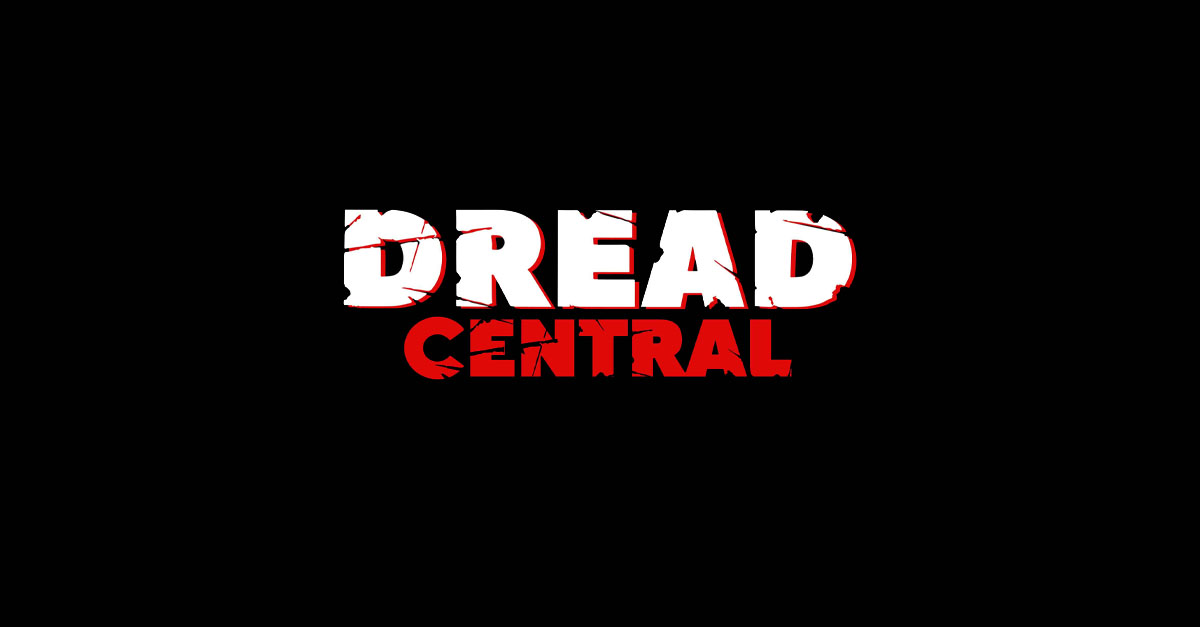Considering the stylistic choices made in the text design, what genre or themes might the entity represented by this text be associated with, and why do these design choices suggest that? The graphic text design, featuring the word 'DREAD' in bold, fragmented typography against a black backdrop, immediately evokes the essence of horror and psychological thriller themes. The jagged edges of the letters resemble sharp cuts or breaks, visualizing the notion of violence or disruption, which are hallmarks of suspenseful narratives. The color red, splattered like blood or highlighting danger, further reinforces the connection to horror, often used to convey intensity and high emotional stakes. The term 'central' beneath, while stylistically less aggressive, anchors the concept, potentially indicating a hub or nexus for content related to the thrills and chills that fans of the horror genre seek. This nuanced approach to design capitalizes on visual metaphors and cultural associations that instinctively resonate with the viewer, nudging them into a state of heightened anticipation typical of horror or thriller experiences. 